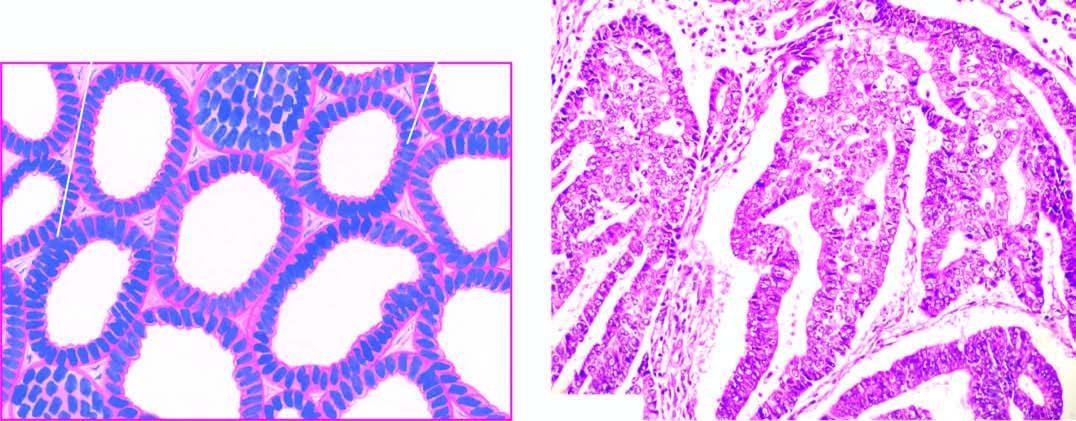what is well-differentiated adenocarcinoma showing closely packed glands with cytologic atypia?
Answer the question using a single word or phrase. The most common histologic pattern 